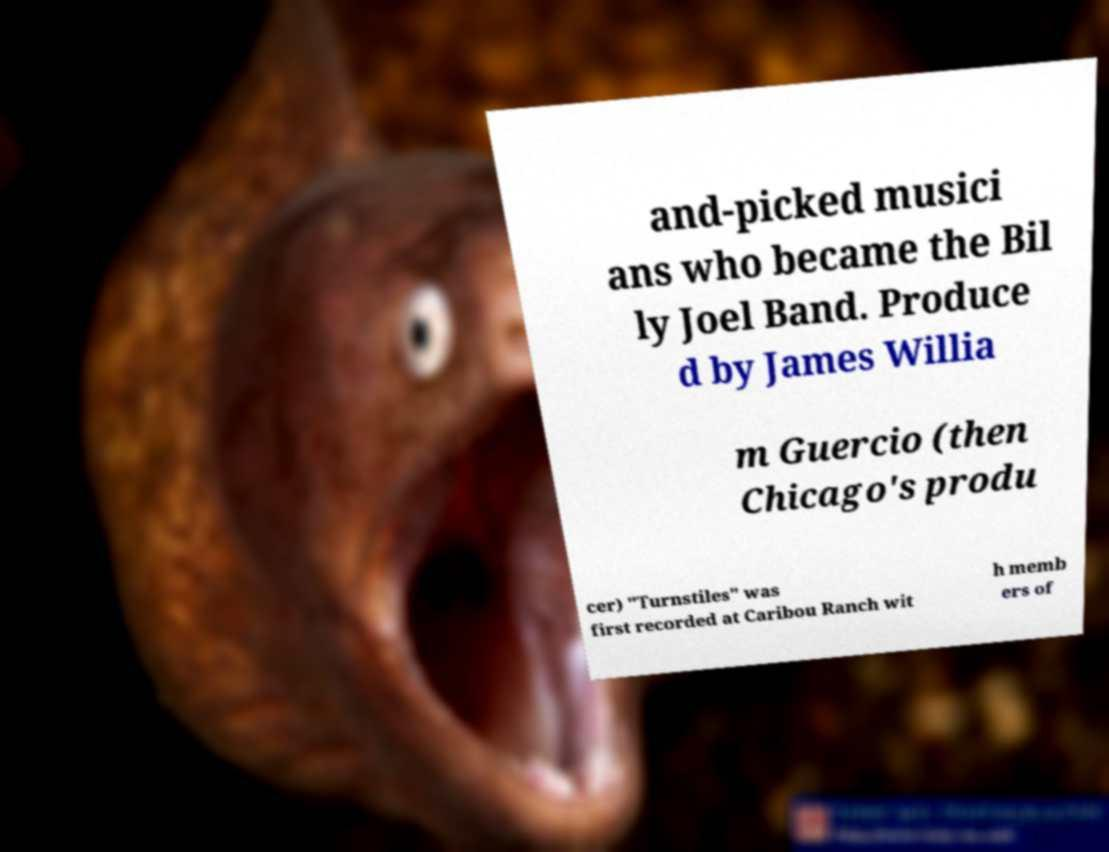Please identify and transcribe the text found in this image. and-picked musici ans who became the Bil ly Joel Band. Produce d by James Willia m Guercio (then Chicago's produ cer) "Turnstiles" was first recorded at Caribou Ranch wit h memb ers of 